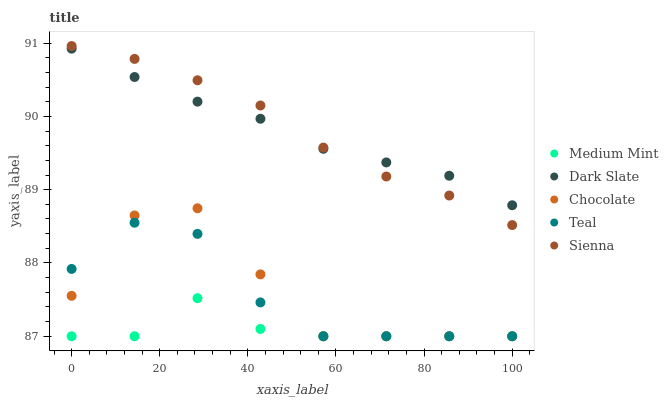Does Medium Mint have the minimum area under the curve?
Answer yes or no. Yes. Does Sienna have the maximum area under the curve?
Answer yes or no. Yes. Does Dark Slate have the minimum area under the curve?
Answer yes or no. No. Does Dark Slate have the maximum area under the curve?
Answer yes or no. No. Is Dark Slate the smoothest?
Answer yes or no. Yes. Is Chocolate the roughest?
Answer yes or no. Yes. Is Sienna the smoothest?
Answer yes or no. No. Is Sienna the roughest?
Answer yes or no. No. Does Medium Mint have the lowest value?
Answer yes or no. Yes. Does Sienna have the lowest value?
Answer yes or no. No. Does Sienna have the highest value?
Answer yes or no. Yes. Does Dark Slate have the highest value?
Answer yes or no. No. Is Chocolate less than Dark Slate?
Answer yes or no. Yes. Is Dark Slate greater than Chocolate?
Answer yes or no. Yes. Does Medium Mint intersect Chocolate?
Answer yes or no. Yes. Is Medium Mint less than Chocolate?
Answer yes or no. No. Is Medium Mint greater than Chocolate?
Answer yes or no. No. Does Chocolate intersect Dark Slate?
Answer yes or no. No. 